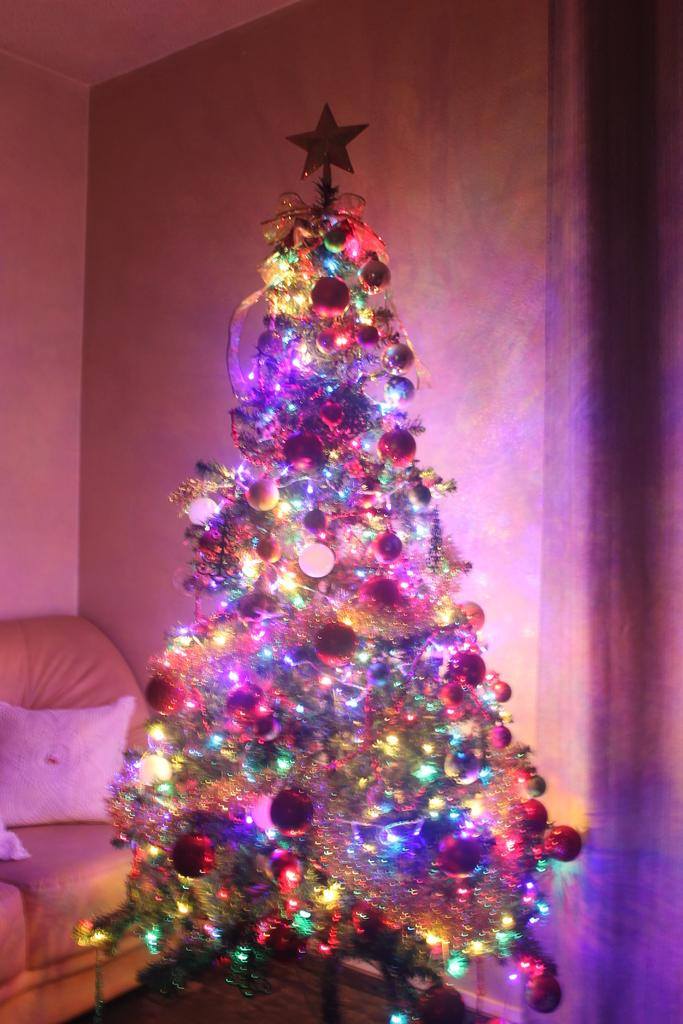What type of decoration is featured in the image? There is a decorative Christmas tree in the image. What type of architectural elements can be seen in the image? There are walls visible in the image. What type of furniture is present in the image? There is a sofa in the image. Can you tell me how many sisters are sitting on the sofa in the image? There is no mention of any sisters in the image, and the image only shows a sofa and a Christmas tree. What type of beetle can be seen crawling on the Christmas tree in the image? There is no beetle present on the Christmas tree in the image. 